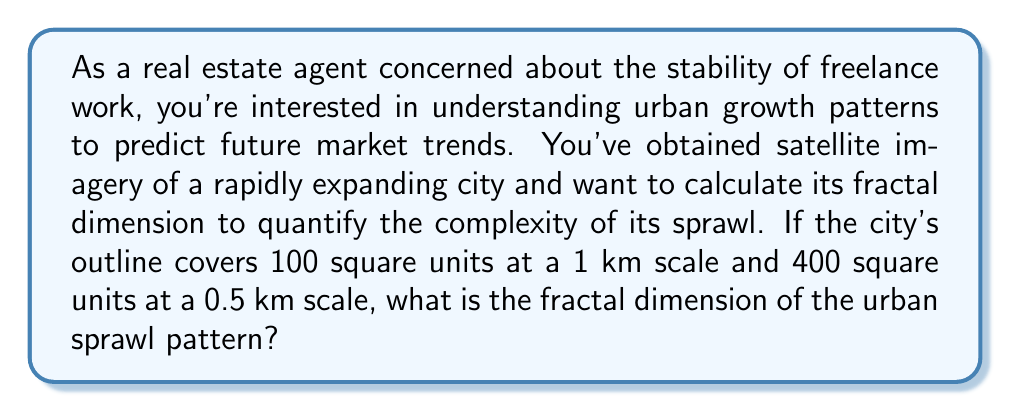What is the answer to this math problem? To calculate the fractal dimension of the urban sprawl pattern, we'll use the box-counting method, which is a common technique in chaos theory and fractal analysis. The fractal dimension $D$ is given by the formula:

$$D = \frac{\log(N_2/N_1)}{\log(r_1/r_2)}$$

Where:
$N_1$ and $N_2$ are the number of boxes needed to cover the pattern at scales $r_1$ and $r_2$, respectively.

Step 1: Identify the given information
- At 1 km scale (r₁), the city covers 100 square units (N₁ = 100)
- At 0.5 km scale (r₂), the city covers 400 square units (N₂ = 400)

Step 2: Set up the equation
$$D = \frac{\log(400/100)}{\log(1/0.5)}$$

Step 3: Simplify the numerator and denominator
$$D = \frac{\log(4)}{\log(2)}$$

Step 4: Calculate the logarithms
$$D = \frac{0.60205999132}{0.30102999566}$$

Step 5: Divide to get the final result
$$D ≈ 1.9999999998$$

The result is very close to 2, which indicates that the urban sprawl pattern is filling the 2-dimensional plane almost completely, suggesting a highly complex and space-filling growth pattern.
Answer: $D ≈ 2$ 